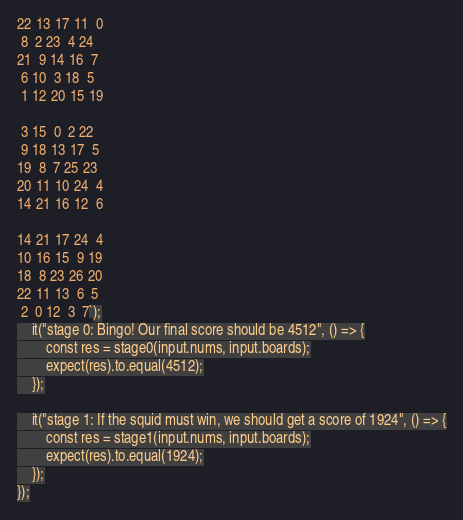<code> <loc_0><loc_0><loc_500><loc_500><_TypeScript_>
22 13 17 11  0
 8  2 23  4 24
21  9 14 16  7
 6 10  3 18  5
 1 12 20 15 19

 3 15  0  2 22
 9 18 13 17  5
19  8  7 25 23
20 11 10 24  4
14 21 16 12  6

14 21 17 24  4
10 16 15  9 19
18  8 23 26 20
22 11 13  6  5
 2  0 12  3  7`);
    it("stage 0: Bingo! Our final score should be 4512", () => {
        const res = stage0(input.nums, input.boards);
        expect(res).to.equal(4512);
    });

    it("stage 1: If the squid must win, we should get a score of 1924", () => {
        const res = stage1(input.nums, input.boards);
        expect(res).to.equal(1924);
    });
});
</code> 